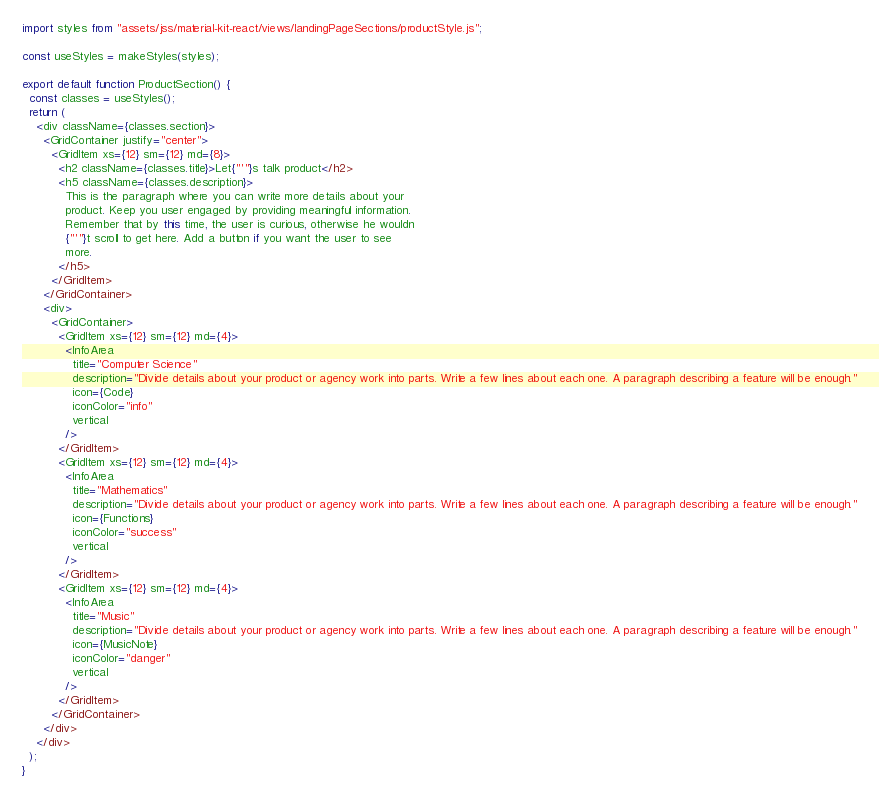Convert code to text. <code><loc_0><loc_0><loc_500><loc_500><_JavaScript_>import styles from "assets/jss/material-kit-react/views/landingPageSections/productStyle.js";

const useStyles = makeStyles(styles);

export default function ProductSection() {
  const classes = useStyles();
  return (
    <div className={classes.section}>
      <GridContainer justify="center">
        <GridItem xs={12} sm={12} md={8}>
          <h2 className={classes.title}>Let{"'"}s talk product</h2>
          <h5 className={classes.description}>
            This is the paragraph where you can write more details about your
            product. Keep you user engaged by providing meaningful information.
            Remember that by this time, the user is curious, otherwise he wouldn
            {"'"}t scroll to get here. Add a button if you want the user to see
            more.
          </h5>
        </GridItem>
      </GridContainer>
      <div>
        <GridContainer>
          <GridItem xs={12} sm={12} md={4}>
            <InfoArea
              title="Computer Science"
              description="Divide details about your product or agency work into parts. Write a few lines about each one. A paragraph describing a feature will be enough."
              icon={Code}
              iconColor="info"
              vertical
            />
          </GridItem>
          <GridItem xs={12} sm={12} md={4}>
            <InfoArea
              title="Mathematics"
              description="Divide details about your product or agency work into parts. Write a few lines about each one. A paragraph describing a feature will be enough."
              icon={Functions}
              iconColor="success"
              vertical
            />
          </GridItem>
          <GridItem xs={12} sm={12} md={4}>
            <InfoArea
              title="Music"
              description="Divide details about your product or agency work into parts. Write a few lines about each one. A paragraph describing a feature will be enough."
              icon={MusicNote}
              iconColor="danger"
              vertical
            />
          </GridItem>
        </GridContainer>
      </div>
    </div>
  );
}
</code> 